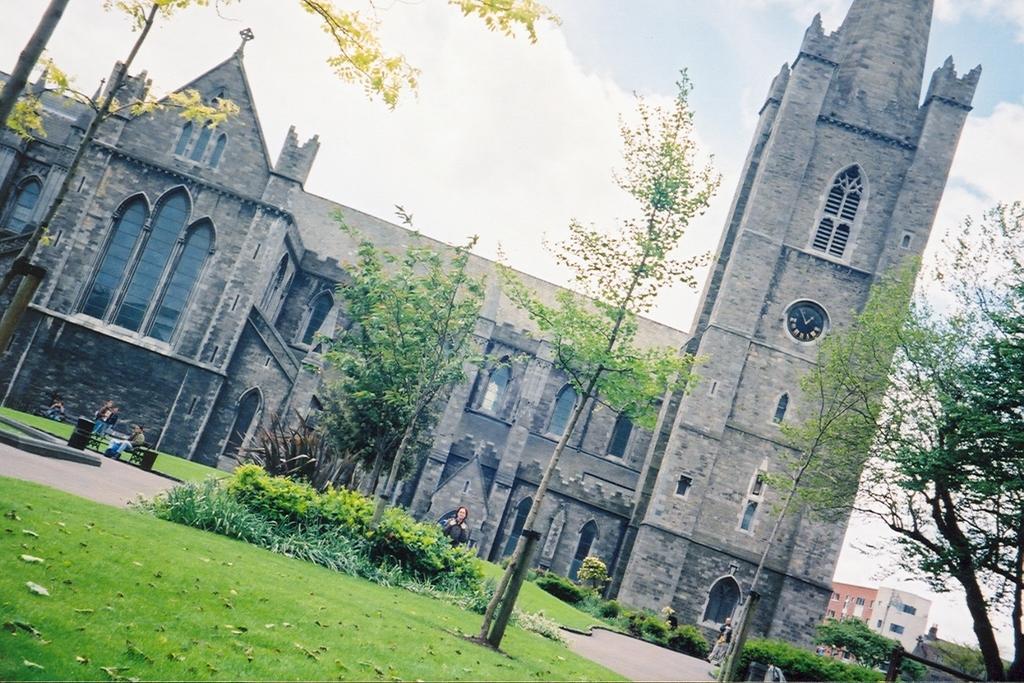Could you give a brief overview of what you see in this image? In this image there is the sky towards the top of the image, there are clouds in the sky, there is a building, there are plants, there are trees, there is grass towards the bottom of the image, there is a man sitting on the bench, there are persons standing, there is an object towards the bottom of the image. 